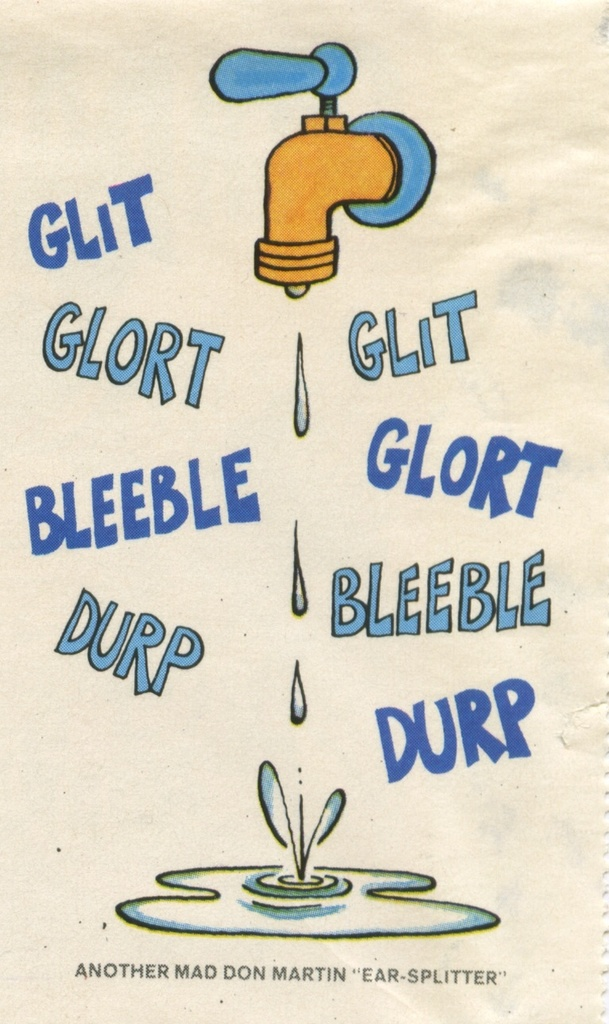What role does the caption play in the context of this image? The caption 'Another Mad Don Martin 'Ear-Splitter'' adds a layer of humor and context to the image. It suggests that the artwork is part of a series by Don Martin, known for his exaggerated and humorous style in illustrations. The term 'Ear-Splitter' humorously exaggerates the noise level of the dripping water, playing into the idea that something as simple as a faucet drip can be perceived as annoyingly loud. 